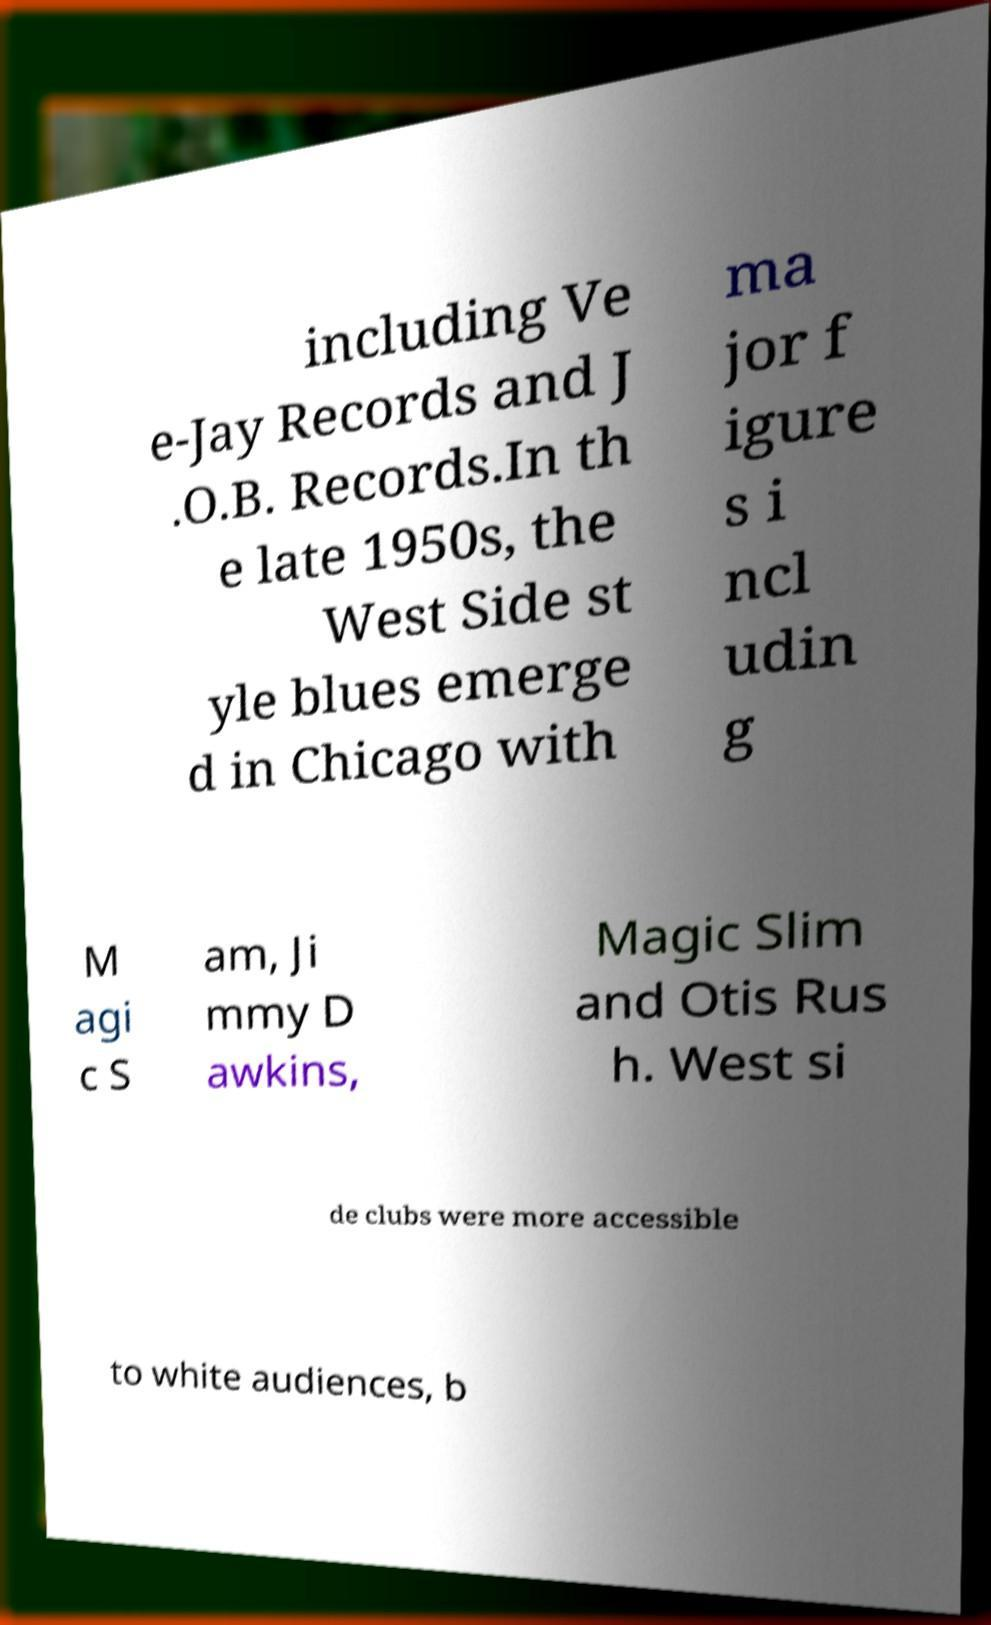Could you extract and type out the text from this image? including Ve e-Jay Records and J .O.B. Records.In th e late 1950s, the West Side st yle blues emerge d in Chicago with ma jor f igure s i ncl udin g M agi c S am, Ji mmy D awkins, Magic Slim and Otis Rus h. West si de clubs were more accessible to white audiences, b 